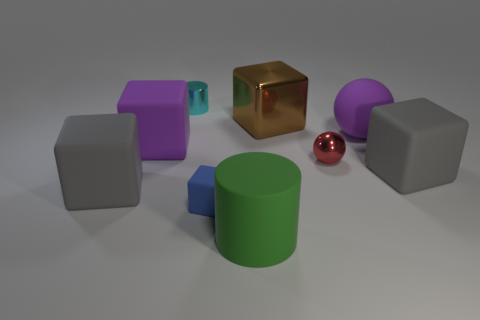Subtract all blue cubes. How many cubes are left? 4 Subtract all tiny matte blocks. How many blocks are left? 4 Subtract all cyan cubes. Subtract all blue balls. How many cubes are left? 5 Add 1 metal cylinders. How many objects exist? 10 Subtract all balls. How many objects are left? 7 Subtract all small green balls. Subtract all big cylinders. How many objects are left? 8 Add 7 small metal cylinders. How many small metal cylinders are left? 8 Add 6 large gray matte blocks. How many large gray matte blocks exist? 8 Subtract 1 cyan cylinders. How many objects are left? 8 